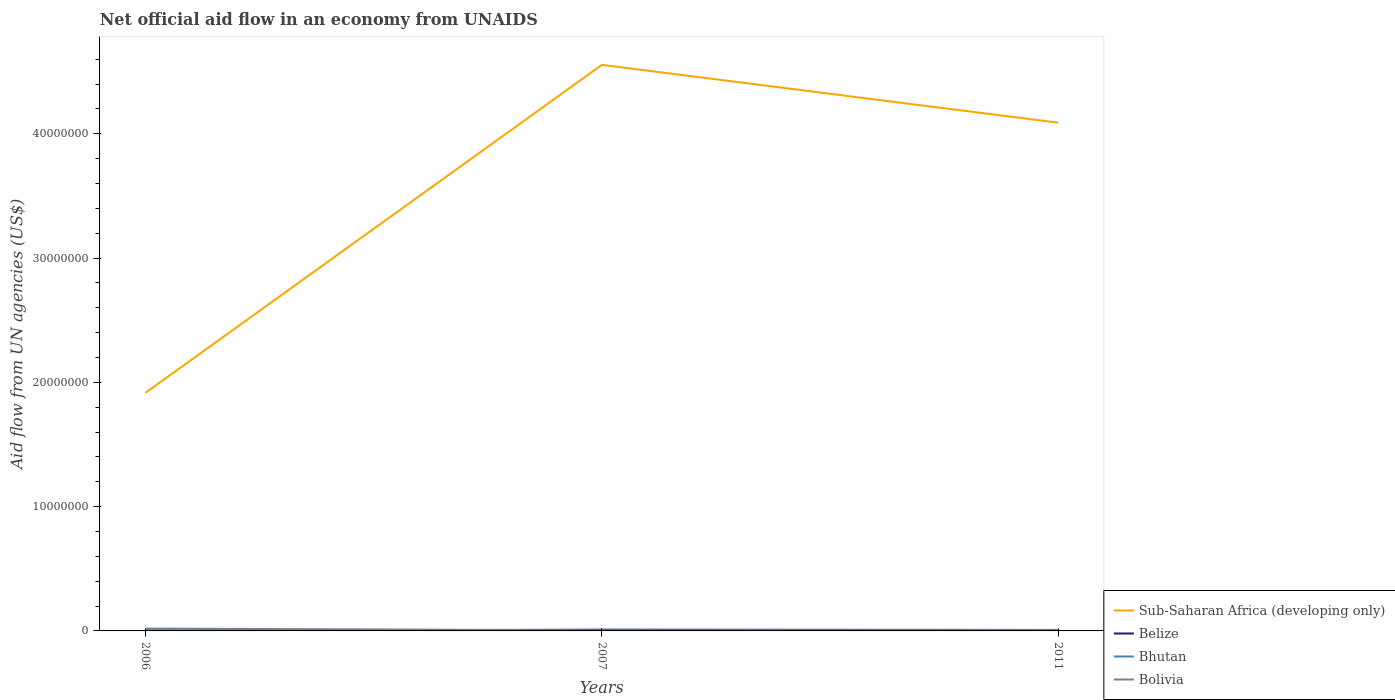How many different coloured lines are there?
Keep it short and to the point. 4. Is the number of lines equal to the number of legend labels?
Keep it short and to the point. Yes. In which year was the net official aid flow in Belize maximum?
Your response must be concise. 2006. What is the difference between the highest and the second highest net official aid flow in Belize?
Your answer should be very brief. 9.00e+04. Is the net official aid flow in Bolivia strictly greater than the net official aid flow in Sub-Saharan Africa (developing only) over the years?
Offer a terse response. Yes. What is the difference between two consecutive major ticks on the Y-axis?
Provide a succinct answer. 1.00e+07. Does the graph contain grids?
Make the answer very short. No. Where does the legend appear in the graph?
Your answer should be compact. Bottom right. How are the legend labels stacked?
Keep it short and to the point. Vertical. What is the title of the graph?
Your answer should be compact. Net official aid flow in an economy from UNAIDS. What is the label or title of the X-axis?
Your answer should be compact. Years. What is the label or title of the Y-axis?
Provide a short and direct response. Aid flow from UN agencies (US$). What is the Aid flow from UN agencies (US$) of Sub-Saharan Africa (developing only) in 2006?
Offer a terse response. 1.92e+07. What is the Aid flow from UN agencies (US$) of Belize in 2006?
Provide a short and direct response. 10000. What is the Aid flow from UN agencies (US$) in Bhutan in 2006?
Keep it short and to the point. 5.00e+04. What is the Aid flow from UN agencies (US$) in Sub-Saharan Africa (developing only) in 2007?
Provide a short and direct response. 4.56e+07. What is the Aid flow from UN agencies (US$) of Belize in 2007?
Give a very brief answer. 1.00e+05. What is the Aid flow from UN agencies (US$) of Sub-Saharan Africa (developing only) in 2011?
Provide a short and direct response. 4.09e+07. What is the Aid flow from UN agencies (US$) in Belize in 2011?
Ensure brevity in your answer.  8.00e+04. What is the Aid flow from UN agencies (US$) in Bolivia in 2011?
Make the answer very short. 7.00e+04. Across all years, what is the maximum Aid flow from UN agencies (US$) of Sub-Saharan Africa (developing only)?
Keep it short and to the point. 4.56e+07. Across all years, what is the maximum Aid flow from UN agencies (US$) of Belize?
Provide a succinct answer. 1.00e+05. Across all years, what is the maximum Aid flow from UN agencies (US$) in Bhutan?
Offer a terse response. 6.00e+04. Across all years, what is the maximum Aid flow from UN agencies (US$) of Bolivia?
Provide a short and direct response. 1.90e+05. Across all years, what is the minimum Aid flow from UN agencies (US$) in Sub-Saharan Africa (developing only)?
Your answer should be compact. 1.92e+07. Across all years, what is the minimum Aid flow from UN agencies (US$) in Belize?
Make the answer very short. 10000. Across all years, what is the minimum Aid flow from UN agencies (US$) in Bhutan?
Your response must be concise. 10000. What is the total Aid flow from UN agencies (US$) in Sub-Saharan Africa (developing only) in the graph?
Offer a very short reply. 1.06e+08. What is the total Aid flow from UN agencies (US$) of Belize in the graph?
Your response must be concise. 1.90e+05. What is the total Aid flow from UN agencies (US$) in Bhutan in the graph?
Ensure brevity in your answer.  1.20e+05. What is the difference between the Aid flow from UN agencies (US$) in Sub-Saharan Africa (developing only) in 2006 and that in 2007?
Keep it short and to the point. -2.64e+07. What is the difference between the Aid flow from UN agencies (US$) in Belize in 2006 and that in 2007?
Provide a succinct answer. -9.00e+04. What is the difference between the Aid flow from UN agencies (US$) in Sub-Saharan Africa (developing only) in 2006 and that in 2011?
Make the answer very short. -2.17e+07. What is the difference between the Aid flow from UN agencies (US$) in Belize in 2006 and that in 2011?
Provide a short and direct response. -7.00e+04. What is the difference between the Aid flow from UN agencies (US$) of Bhutan in 2006 and that in 2011?
Make the answer very short. -10000. What is the difference between the Aid flow from UN agencies (US$) of Sub-Saharan Africa (developing only) in 2007 and that in 2011?
Your answer should be very brief. 4.65e+06. What is the difference between the Aid flow from UN agencies (US$) of Belize in 2007 and that in 2011?
Your answer should be very brief. 2.00e+04. What is the difference between the Aid flow from UN agencies (US$) of Bhutan in 2007 and that in 2011?
Your answer should be compact. -5.00e+04. What is the difference between the Aid flow from UN agencies (US$) in Sub-Saharan Africa (developing only) in 2006 and the Aid flow from UN agencies (US$) in Belize in 2007?
Your answer should be very brief. 1.91e+07. What is the difference between the Aid flow from UN agencies (US$) in Sub-Saharan Africa (developing only) in 2006 and the Aid flow from UN agencies (US$) in Bhutan in 2007?
Your answer should be compact. 1.92e+07. What is the difference between the Aid flow from UN agencies (US$) of Sub-Saharan Africa (developing only) in 2006 and the Aid flow from UN agencies (US$) of Bolivia in 2007?
Keep it short and to the point. 1.91e+07. What is the difference between the Aid flow from UN agencies (US$) of Belize in 2006 and the Aid flow from UN agencies (US$) of Bhutan in 2007?
Offer a terse response. 0. What is the difference between the Aid flow from UN agencies (US$) in Belize in 2006 and the Aid flow from UN agencies (US$) in Bolivia in 2007?
Ensure brevity in your answer.  -4.00e+04. What is the difference between the Aid flow from UN agencies (US$) in Bhutan in 2006 and the Aid flow from UN agencies (US$) in Bolivia in 2007?
Offer a terse response. 0. What is the difference between the Aid flow from UN agencies (US$) in Sub-Saharan Africa (developing only) in 2006 and the Aid flow from UN agencies (US$) in Belize in 2011?
Ensure brevity in your answer.  1.91e+07. What is the difference between the Aid flow from UN agencies (US$) of Sub-Saharan Africa (developing only) in 2006 and the Aid flow from UN agencies (US$) of Bhutan in 2011?
Give a very brief answer. 1.91e+07. What is the difference between the Aid flow from UN agencies (US$) of Sub-Saharan Africa (developing only) in 2006 and the Aid flow from UN agencies (US$) of Bolivia in 2011?
Your response must be concise. 1.91e+07. What is the difference between the Aid flow from UN agencies (US$) of Belize in 2006 and the Aid flow from UN agencies (US$) of Bolivia in 2011?
Your response must be concise. -6.00e+04. What is the difference between the Aid flow from UN agencies (US$) in Sub-Saharan Africa (developing only) in 2007 and the Aid flow from UN agencies (US$) in Belize in 2011?
Provide a succinct answer. 4.55e+07. What is the difference between the Aid flow from UN agencies (US$) of Sub-Saharan Africa (developing only) in 2007 and the Aid flow from UN agencies (US$) of Bhutan in 2011?
Offer a very short reply. 4.55e+07. What is the difference between the Aid flow from UN agencies (US$) in Sub-Saharan Africa (developing only) in 2007 and the Aid flow from UN agencies (US$) in Bolivia in 2011?
Your answer should be compact. 4.55e+07. What is the difference between the Aid flow from UN agencies (US$) in Belize in 2007 and the Aid flow from UN agencies (US$) in Bhutan in 2011?
Give a very brief answer. 4.00e+04. What is the difference between the Aid flow from UN agencies (US$) in Belize in 2007 and the Aid flow from UN agencies (US$) in Bolivia in 2011?
Offer a very short reply. 3.00e+04. What is the average Aid flow from UN agencies (US$) in Sub-Saharan Africa (developing only) per year?
Provide a short and direct response. 3.52e+07. What is the average Aid flow from UN agencies (US$) of Belize per year?
Your answer should be very brief. 6.33e+04. What is the average Aid flow from UN agencies (US$) in Bolivia per year?
Provide a short and direct response. 1.03e+05. In the year 2006, what is the difference between the Aid flow from UN agencies (US$) of Sub-Saharan Africa (developing only) and Aid flow from UN agencies (US$) of Belize?
Give a very brief answer. 1.92e+07. In the year 2006, what is the difference between the Aid flow from UN agencies (US$) in Sub-Saharan Africa (developing only) and Aid flow from UN agencies (US$) in Bhutan?
Provide a short and direct response. 1.91e+07. In the year 2006, what is the difference between the Aid flow from UN agencies (US$) of Sub-Saharan Africa (developing only) and Aid flow from UN agencies (US$) of Bolivia?
Your answer should be very brief. 1.90e+07. In the year 2006, what is the difference between the Aid flow from UN agencies (US$) in Belize and Aid flow from UN agencies (US$) in Bhutan?
Give a very brief answer. -4.00e+04. In the year 2006, what is the difference between the Aid flow from UN agencies (US$) in Belize and Aid flow from UN agencies (US$) in Bolivia?
Make the answer very short. -1.80e+05. In the year 2006, what is the difference between the Aid flow from UN agencies (US$) in Bhutan and Aid flow from UN agencies (US$) in Bolivia?
Your answer should be compact. -1.40e+05. In the year 2007, what is the difference between the Aid flow from UN agencies (US$) of Sub-Saharan Africa (developing only) and Aid flow from UN agencies (US$) of Belize?
Offer a terse response. 4.54e+07. In the year 2007, what is the difference between the Aid flow from UN agencies (US$) of Sub-Saharan Africa (developing only) and Aid flow from UN agencies (US$) of Bhutan?
Your response must be concise. 4.55e+07. In the year 2007, what is the difference between the Aid flow from UN agencies (US$) in Sub-Saharan Africa (developing only) and Aid flow from UN agencies (US$) in Bolivia?
Provide a short and direct response. 4.55e+07. In the year 2011, what is the difference between the Aid flow from UN agencies (US$) of Sub-Saharan Africa (developing only) and Aid flow from UN agencies (US$) of Belize?
Provide a succinct answer. 4.08e+07. In the year 2011, what is the difference between the Aid flow from UN agencies (US$) in Sub-Saharan Africa (developing only) and Aid flow from UN agencies (US$) in Bhutan?
Keep it short and to the point. 4.08e+07. In the year 2011, what is the difference between the Aid flow from UN agencies (US$) of Sub-Saharan Africa (developing only) and Aid flow from UN agencies (US$) of Bolivia?
Ensure brevity in your answer.  4.08e+07. In the year 2011, what is the difference between the Aid flow from UN agencies (US$) in Belize and Aid flow from UN agencies (US$) in Bhutan?
Provide a succinct answer. 2.00e+04. In the year 2011, what is the difference between the Aid flow from UN agencies (US$) in Belize and Aid flow from UN agencies (US$) in Bolivia?
Your answer should be very brief. 10000. What is the ratio of the Aid flow from UN agencies (US$) of Sub-Saharan Africa (developing only) in 2006 to that in 2007?
Offer a very short reply. 0.42. What is the ratio of the Aid flow from UN agencies (US$) in Belize in 2006 to that in 2007?
Your answer should be compact. 0.1. What is the ratio of the Aid flow from UN agencies (US$) in Bhutan in 2006 to that in 2007?
Offer a terse response. 5. What is the ratio of the Aid flow from UN agencies (US$) in Bolivia in 2006 to that in 2007?
Offer a terse response. 3.8. What is the ratio of the Aid flow from UN agencies (US$) in Sub-Saharan Africa (developing only) in 2006 to that in 2011?
Offer a terse response. 0.47. What is the ratio of the Aid flow from UN agencies (US$) of Bolivia in 2006 to that in 2011?
Your answer should be very brief. 2.71. What is the ratio of the Aid flow from UN agencies (US$) in Sub-Saharan Africa (developing only) in 2007 to that in 2011?
Keep it short and to the point. 1.11. What is the ratio of the Aid flow from UN agencies (US$) of Bolivia in 2007 to that in 2011?
Ensure brevity in your answer.  0.71. What is the difference between the highest and the second highest Aid flow from UN agencies (US$) in Sub-Saharan Africa (developing only)?
Your response must be concise. 4.65e+06. What is the difference between the highest and the second highest Aid flow from UN agencies (US$) in Belize?
Provide a succinct answer. 2.00e+04. What is the difference between the highest and the lowest Aid flow from UN agencies (US$) of Sub-Saharan Africa (developing only)?
Your answer should be very brief. 2.64e+07. What is the difference between the highest and the lowest Aid flow from UN agencies (US$) of Bolivia?
Ensure brevity in your answer.  1.40e+05. 